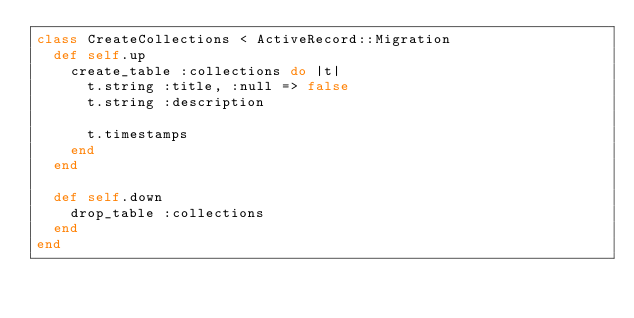Convert code to text. <code><loc_0><loc_0><loc_500><loc_500><_Ruby_>class CreateCollections < ActiveRecord::Migration
  def self.up
    create_table :collections do |t|
      t.string :title, :null => false
      t.string :description

      t.timestamps
    end
  end

  def self.down
    drop_table :collections
  end
end
</code> 